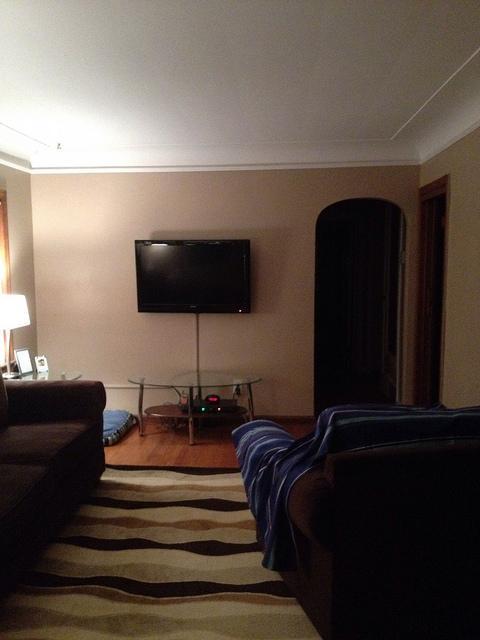How many people are in the room?
Give a very brief answer. 0. How many couches are there?
Give a very brief answer. 2. 